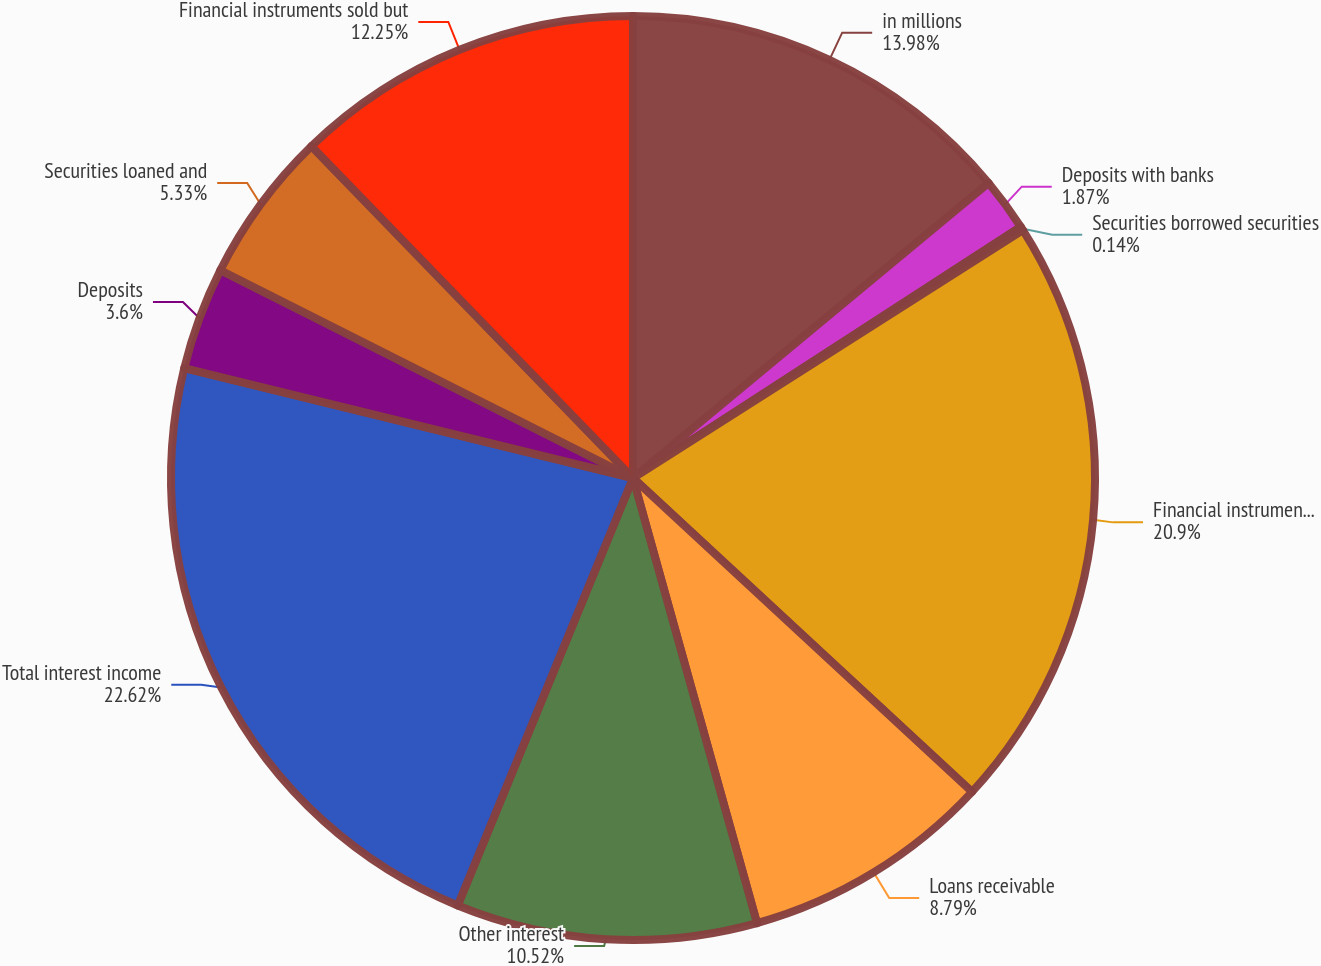<chart> <loc_0><loc_0><loc_500><loc_500><pie_chart><fcel>in millions<fcel>Deposits with banks<fcel>Securities borrowed securities<fcel>Financial instruments owned at<fcel>Loans receivable<fcel>Other interest<fcel>Total interest income<fcel>Deposits<fcel>Securities loaned and<fcel>Financial instruments sold but<nl><fcel>13.98%<fcel>1.87%<fcel>0.14%<fcel>20.9%<fcel>8.79%<fcel>10.52%<fcel>22.63%<fcel>3.6%<fcel>5.33%<fcel>12.25%<nl></chart> 